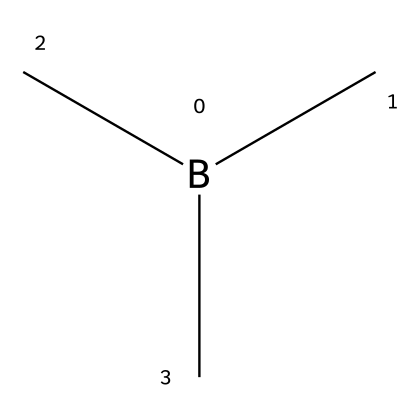How many carbon atoms are in trimethylborane? The SMILES representation shows three methyl groups (C) connected to a boron atom (B). Each methyl group consists of one carbon atom. Therefore, there are three carbon atoms in total.
Answer: three What type of bonding is present in trimethylborane? The structure indicates that trimethylborane is characterized by covalent bonding between the boron atom and the three carbon atoms attached to it. Covalent bonds are formed by the sharing of electron pairs, which is evident in the structure of this molecule.
Answer: covalent What is the total number of atoms in trimethylborane? To calculate the total number of atoms, count the atoms from the SMILES: one boron atom (B), three carbon atoms (C), and nine hydrogen atoms (H) from the three methyl groups (3 CH3, contributing 9 H). Adding these gives a total of 13 atoms.
Answer: thirteen Which functional group is represented in trimethylborane? The presence of boron as the central atom bonded to carbon atoms indicates that this chemical belongs to the class of organoborane compounds. Organoboranes are characterized by the presence of boron in their molecular structure.
Answer: organoborane How many hydrogen atoms are present in trimethylborane? Each methyl group contributes three hydrogen atoms and there are three such groups. Thus, the total number of hydrogen atoms is 3 groups × 3 H each = 9 hydrogen atoms.
Answer: nine What is the hybridization state of the boron atom in trimethylborane? The boron atom in trimethylborane forms three sigma bonds with the carbon atoms, indicating that it has an sp3 hybridization state. This means the boron uses its s and two p orbitals to form four hybrid orbitals, which leads to a tetrahedral arrangement.
Answer: sp3 What makes trimethylborane a useful reagent in chemical synthesis? Trimethylborane's ability to form stable complexes with other compounds, along with its reactivity towards nucleophiles due to the electrophilic nature of boron, makes it valuable in organic synthesis as a reagent.
Answer: reactivity 